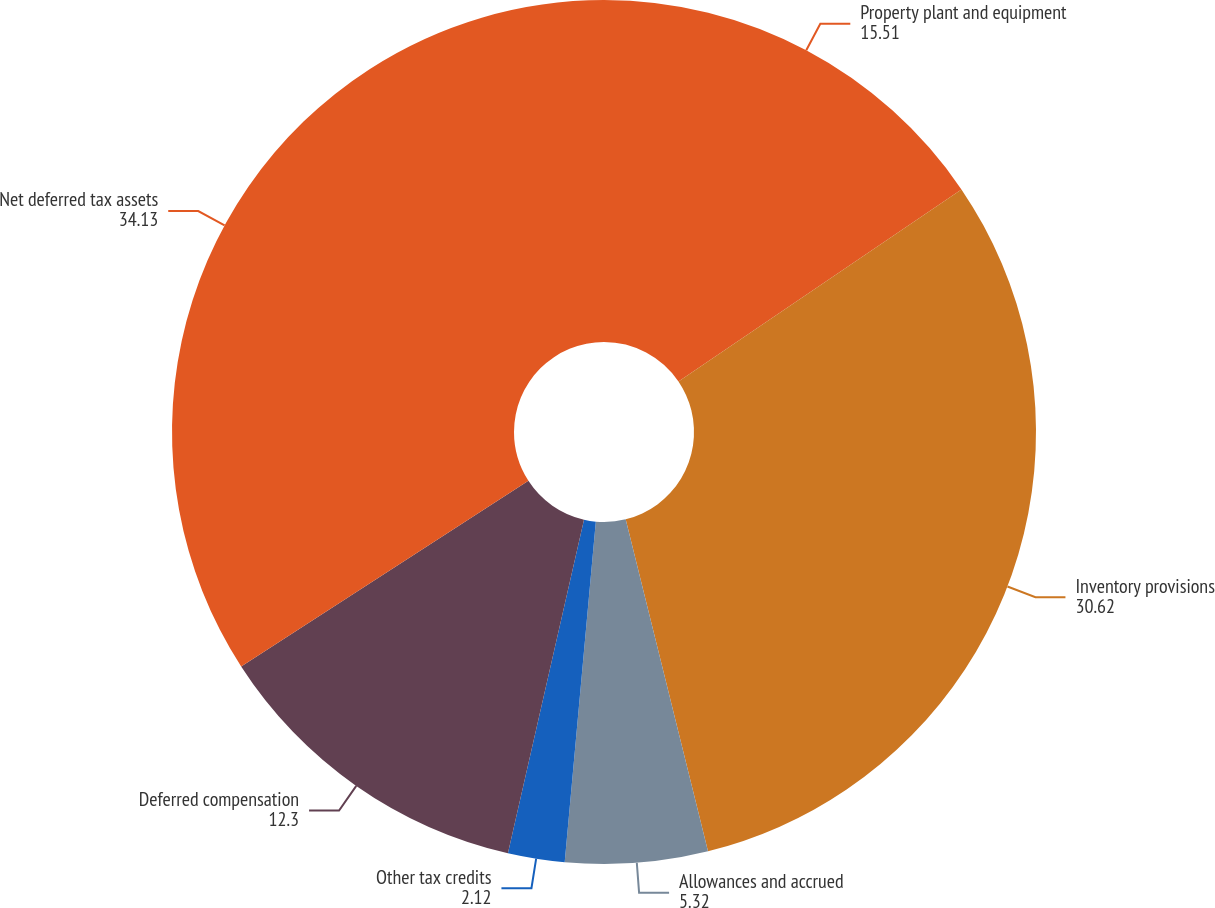Convert chart. <chart><loc_0><loc_0><loc_500><loc_500><pie_chart><fcel>Property plant and equipment<fcel>Inventory provisions<fcel>Allowances and accrued<fcel>Other tax credits<fcel>Deferred compensation<fcel>Net deferred tax assets<nl><fcel>15.51%<fcel>30.62%<fcel>5.32%<fcel>2.12%<fcel>12.3%<fcel>34.13%<nl></chart> 